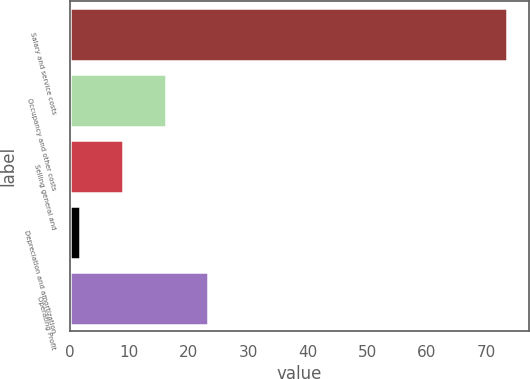Convert chart. <chart><loc_0><loc_0><loc_500><loc_500><bar_chart><fcel>Salary and service costs<fcel>Occupancy and other costs<fcel>Selling general and<fcel>Depreciation and amortization<fcel>Operating Profit<nl><fcel>73.5<fcel>16.14<fcel>8.97<fcel>1.8<fcel>23.31<nl></chart> 